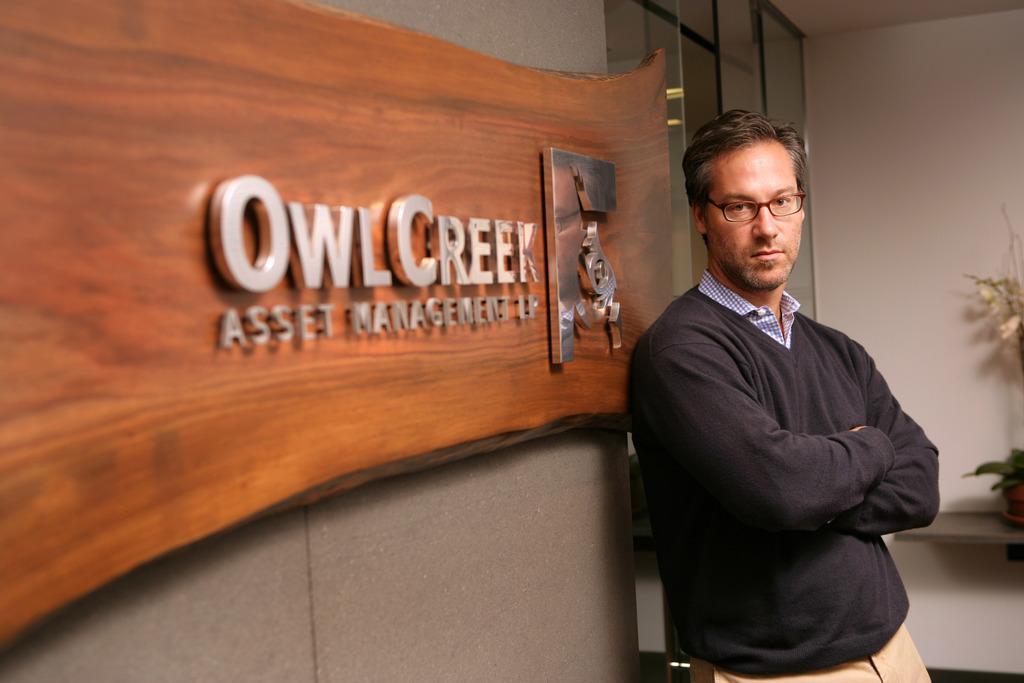Can you describe this image briefly? In this picture there is a man who is wearing spectacle, sweater, shirt and trouser. He is standing near to the wall. On the wall we can see a wooden board on which we can see the company name. In the background there is a glass door and plant. 